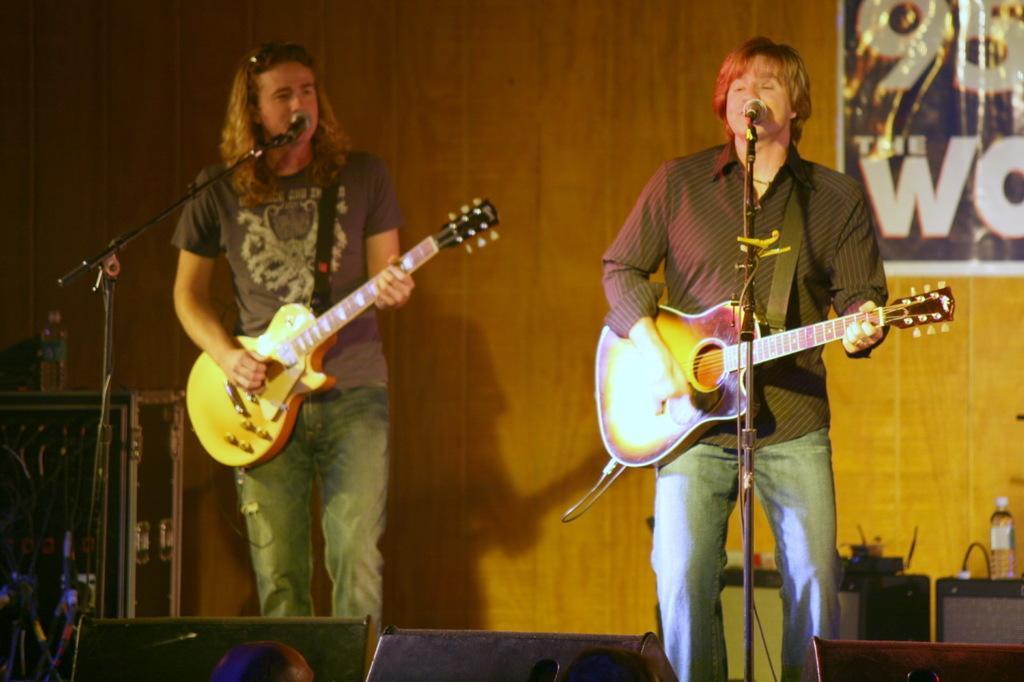Please provide a concise description of this image. In this image two persons are standing on the stage and holding a guitar. There are playing a musical instruments. There is a mic and a stand. At the back side there is a banner and a yellow colored background. There is a water bottle and a speakers. 